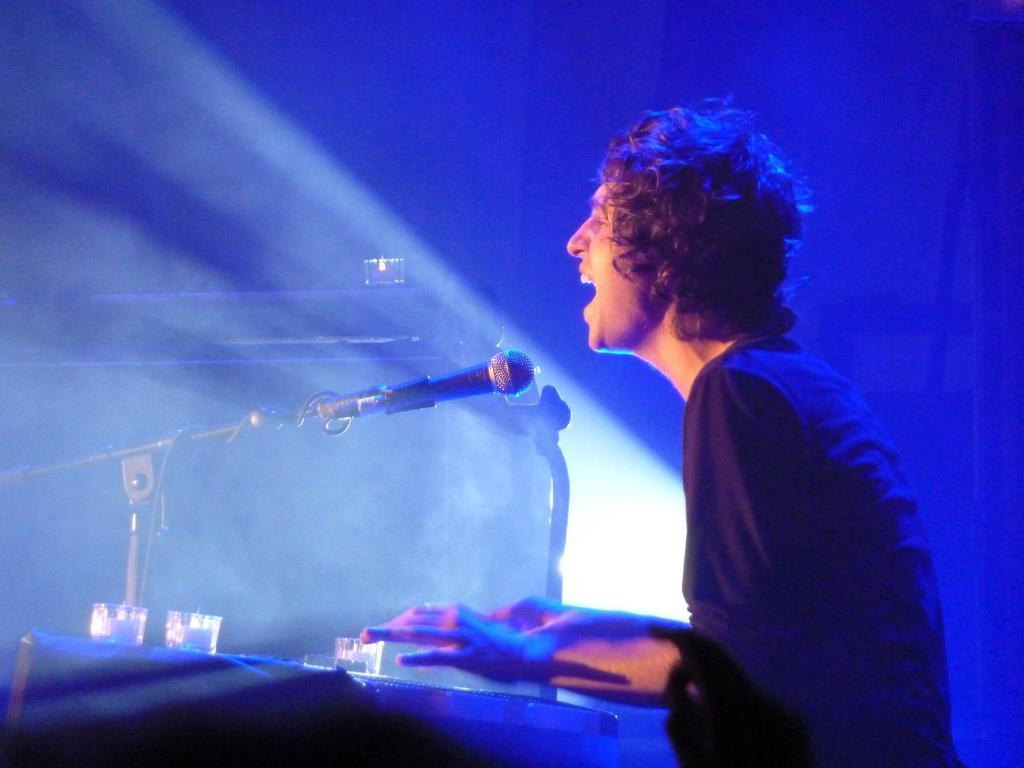What is the main subject of the image? There is a person in the image. What is the person wearing? The person is wearing a black T-shirt. What activity is the person engaged in? The person is playing DJ. What object is in front of the person? There is a microphone in front of the person. What color is the light in the background of the image? There is blue light in the background of the image. What type of pleasure can be seen on the person's face while playing DJ in the image? There is no indication of the person's emotions or facial expressions in the image, so it cannot be determined if they are experiencing pleasure. Can you tell me how many patches are on the person's black T-shirt in the image? The provided facts do not mention any patches on the person's black T-shirt, so it cannot be determined how many patches there are. 